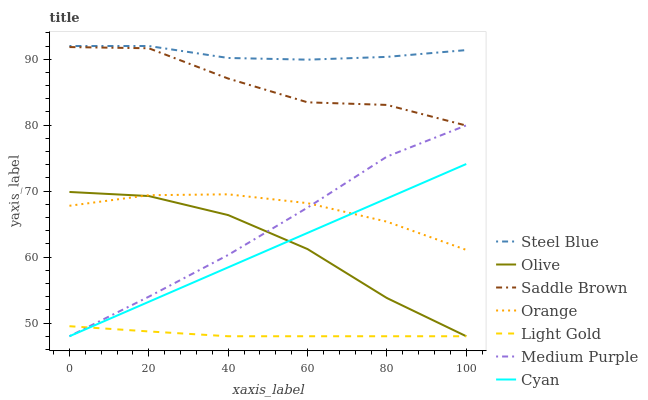Does Light Gold have the minimum area under the curve?
Answer yes or no. Yes. Does Steel Blue have the maximum area under the curve?
Answer yes or no. Yes. Does Medium Purple have the minimum area under the curve?
Answer yes or no. No. Does Medium Purple have the maximum area under the curve?
Answer yes or no. No. Is Cyan the smoothest?
Answer yes or no. Yes. Is Saddle Brown the roughest?
Answer yes or no. Yes. Is Medium Purple the smoothest?
Answer yes or no. No. Is Medium Purple the roughest?
Answer yes or no. No. Does Medium Purple have the lowest value?
Answer yes or no. Yes. Does Orange have the lowest value?
Answer yes or no. No. Does Steel Blue have the highest value?
Answer yes or no. Yes. Does Medium Purple have the highest value?
Answer yes or no. No. Is Olive less than Saddle Brown?
Answer yes or no. Yes. Is Steel Blue greater than Orange?
Answer yes or no. Yes. Does Saddle Brown intersect Medium Purple?
Answer yes or no. Yes. Is Saddle Brown less than Medium Purple?
Answer yes or no. No. Is Saddle Brown greater than Medium Purple?
Answer yes or no. No. Does Olive intersect Saddle Brown?
Answer yes or no. No. 